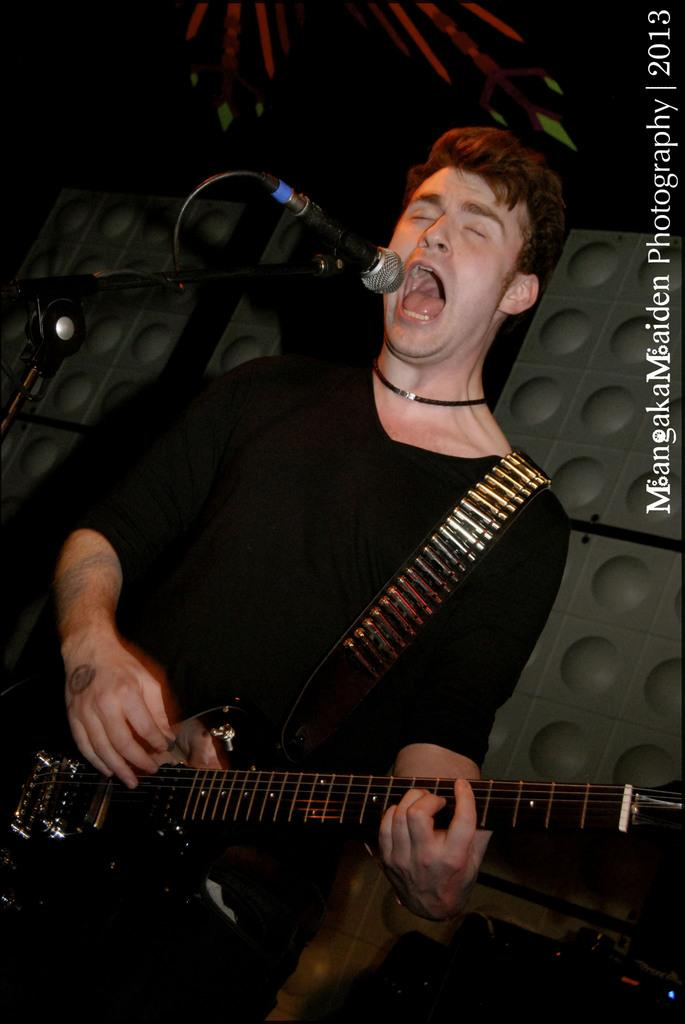What is the man in the image doing? The man is playing a guitar and singing. What tool is the man using to amplify his voice? The man is using a microphone. What scientific theory does the man present in the image? The image does not depict the man presenting a scientific theory; he is playing a guitar and singing. 